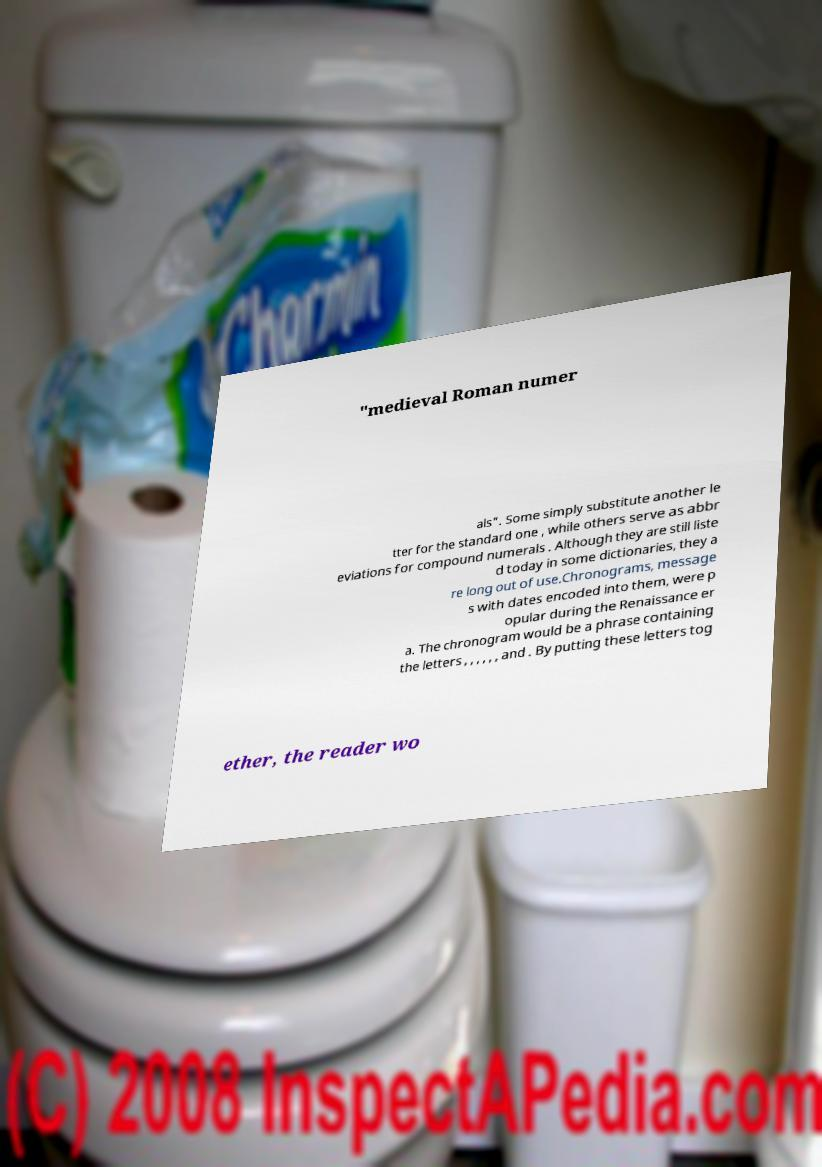Can you accurately transcribe the text from the provided image for me? "medieval Roman numer als". Some simply substitute another le tter for the standard one , while others serve as abbr eviations for compound numerals . Although they are still liste d today in some dictionaries, they a re long out of use.Chronograms, message s with dates encoded into them, were p opular during the Renaissance er a. The chronogram would be a phrase containing the letters , , , , , , and . By putting these letters tog ether, the reader wo 